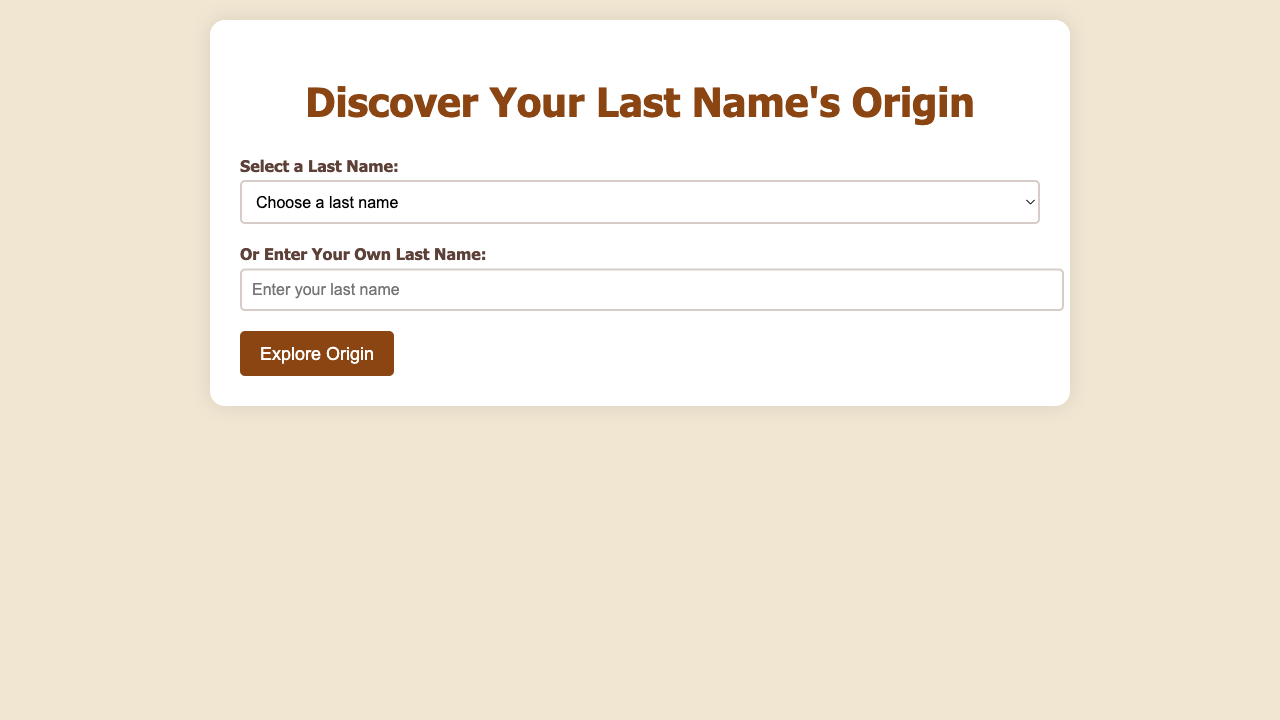What is the title of the document? The title of the document is specified in the HTML `<title>` tag, which is "Last Name Origins Explorer".
Answer: Last Name Origins Explorer What is the most common surname in Vietnam? The document provides specific information about surnames and states that "Nguyen" is the most common surname in Vietnam.
Answer: Nguyen What does the last name "Smith" mean? The document includes a description of the meaning of the last name "Smith", which is derived from the Old English word 'smitan', meaning 'to smite or strike'.
Answer: Derived from the Old English word 'smitan', meaning 'to smite or strike' What cultural significance does "Müller" have? The document discusses cultural significance and states that "it emphasizes the historical importance of agriculture and trade in German culture".
Answer: Emphasizes the historical importance of agriculture and trade in German culture How many last names are listed in the document? By counting the options provided in the select dropdown, we can find that there are six last names listed in the document.
Answer: Six What does "Tanaka" mean? The document states the meaning of "Tanaka" as 'rice field in the middle', highlighting its connection to agriculture.
Answer: Rice field in the middle Which surname reflects the deep agricultural roots in Japan? The document mentions the surname "Tanaka" in connection with agriculture and its significance in Japan's culture.
Answer: Tanaka What is the origin of the surname "Khan"? The document provides the origin of "Khan" as being from Central Asia.
Answer: Central Asia 